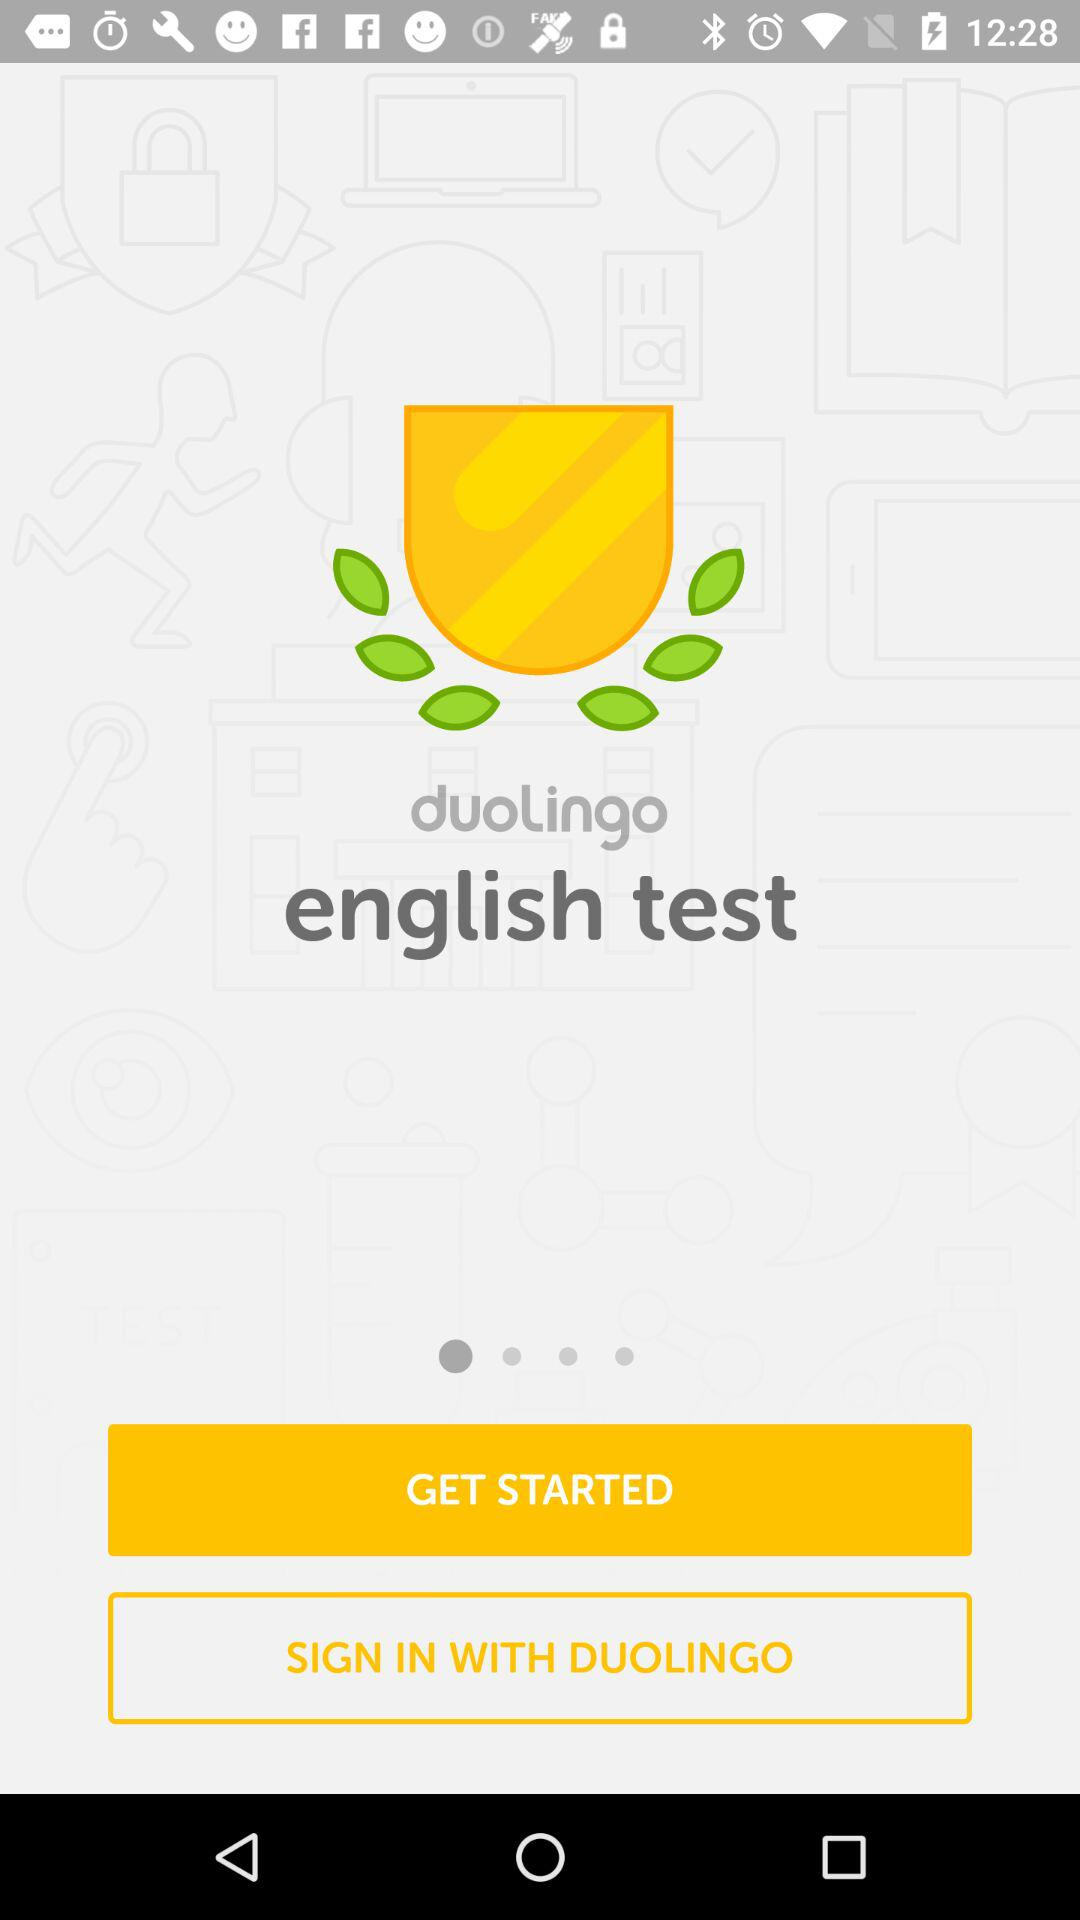What is the name of the application? The name of the application is "duolingo english test". 